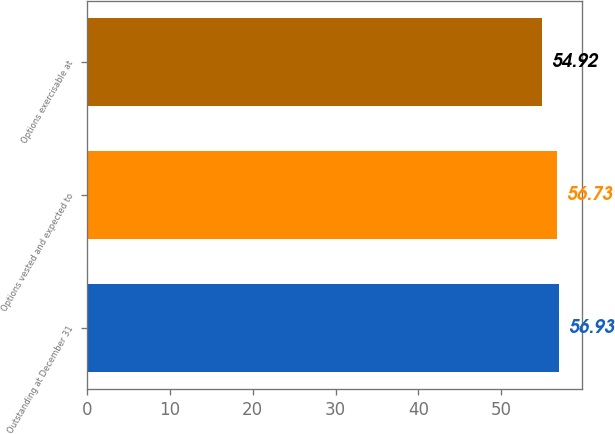<chart> <loc_0><loc_0><loc_500><loc_500><bar_chart><fcel>Outstanding at December 31<fcel>Options vested and expected to<fcel>Options exercisable at<nl><fcel>56.93<fcel>56.73<fcel>54.92<nl></chart> 